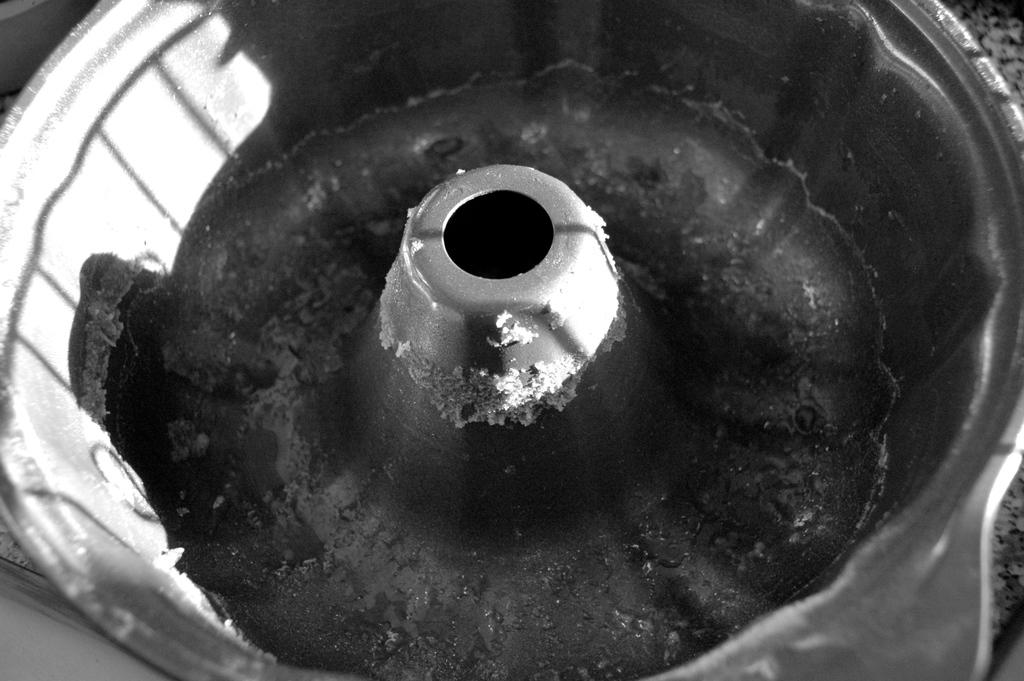What is the color scheme of the image? The image is black and white. What object can be seen in the image? There is a cake pan in the image. What type of seed is growing in the cake pan in the image? There is no seed or plant growing in the cake pan in the image; it is an empty pan. How many stars can be seen in the image? There are no stars visible in the image, as it is a black and white image of a cake pan. 